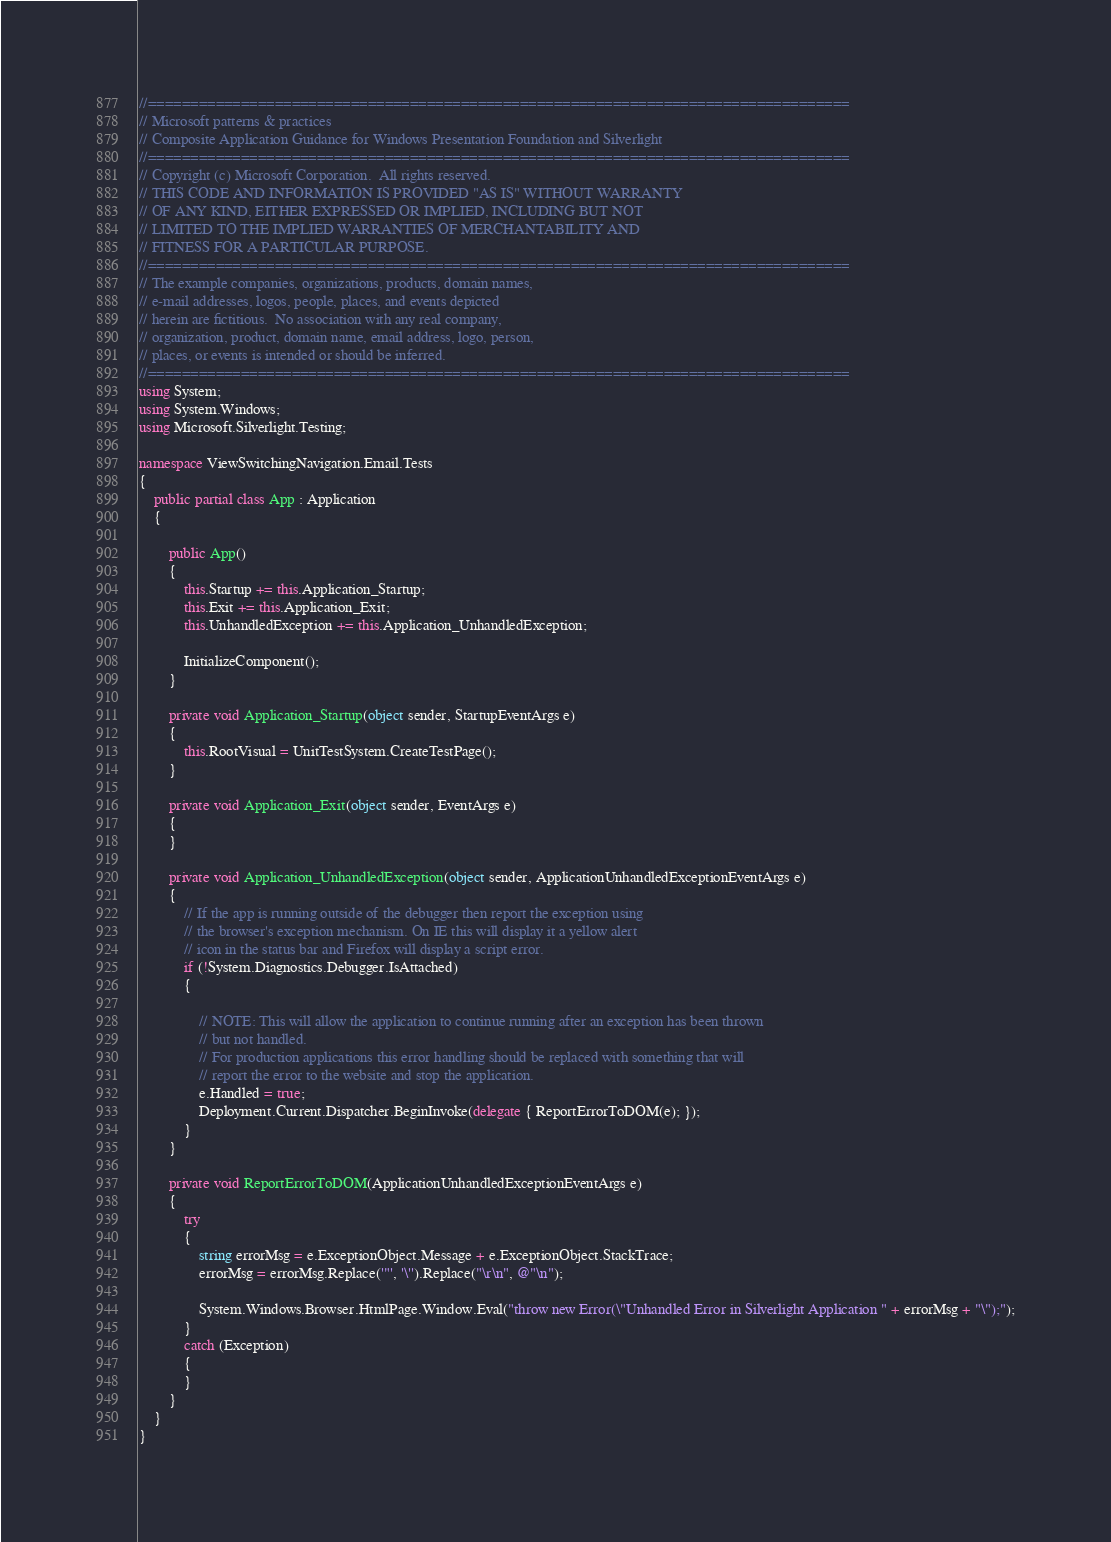<code> <loc_0><loc_0><loc_500><loc_500><_C#_>//===================================================================================
// Microsoft patterns & practices
// Composite Application Guidance for Windows Presentation Foundation and Silverlight
//===================================================================================
// Copyright (c) Microsoft Corporation.  All rights reserved.
// THIS CODE AND INFORMATION IS PROVIDED "AS IS" WITHOUT WARRANTY
// OF ANY KIND, EITHER EXPRESSED OR IMPLIED, INCLUDING BUT NOT
// LIMITED TO THE IMPLIED WARRANTIES OF MERCHANTABILITY AND
// FITNESS FOR A PARTICULAR PURPOSE.
//===================================================================================
// The example companies, organizations, products, domain names,
// e-mail addresses, logos, people, places, and events depicted
// herein are fictitious.  No association with any real company,
// organization, product, domain name, email address, logo, person,
// places, or events is intended or should be inferred.
//===================================================================================
using System;
using System.Windows;
using Microsoft.Silverlight.Testing;

namespace ViewSwitchingNavigation.Email.Tests
{
    public partial class App : Application
    {

        public App()
        {
            this.Startup += this.Application_Startup;
            this.Exit += this.Application_Exit;
            this.UnhandledException += this.Application_UnhandledException;

            InitializeComponent();
        }

        private void Application_Startup(object sender, StartupEventArgs e)
        {
            this.RootVisual = UnitTestSystem.CreateTestPage();
        }

        private void Application_Exit(object sender, EventArgs e)
        {
        }

        private void Application_UnhandledException(object sender, ApplicationUnhandledExceptionEventArgs e)
        {
            // If the app is running outside of the debugger then report the exception using
            // the browser's exception mechanism. On IE this will display it a yellow alert 
            // icon in the status bar and Firefox will display a script error.
            if (!System.Diagnostics.Debugger.IsAttached)
            {

                // NOTE: This will allow the application to continue running after an exception has been thrown
                // but not handled. 
                // For production applications this error handling should be replaced with something that will 
                // report the error to the website and stop the application.
                e.Handled = true;
                Deployment.Current.Dispatcher.BeginInvoke(delegate { ReportErrorToDOM(e); });
            }
        }

        private void ReportErrorToDOM(ApplicationUnhandledExceptionEventArgs e)
        {
            try
            {
                string errorMsg = e.ExceptionObject.Message + e.ExceptionObject.StackTrace;
                errorMsg = errorMsg.Replace('"', '\'').Replace("\r\n", @"\n");

                System.Windows.Browser.HtmlPage.Window.Eval("throw new Error(\"Unhandled Error in Silverlight Application " + errorMsg + "\");");
            }
            catch (Exception)
            {
            }
        }
    }
}
</code> 